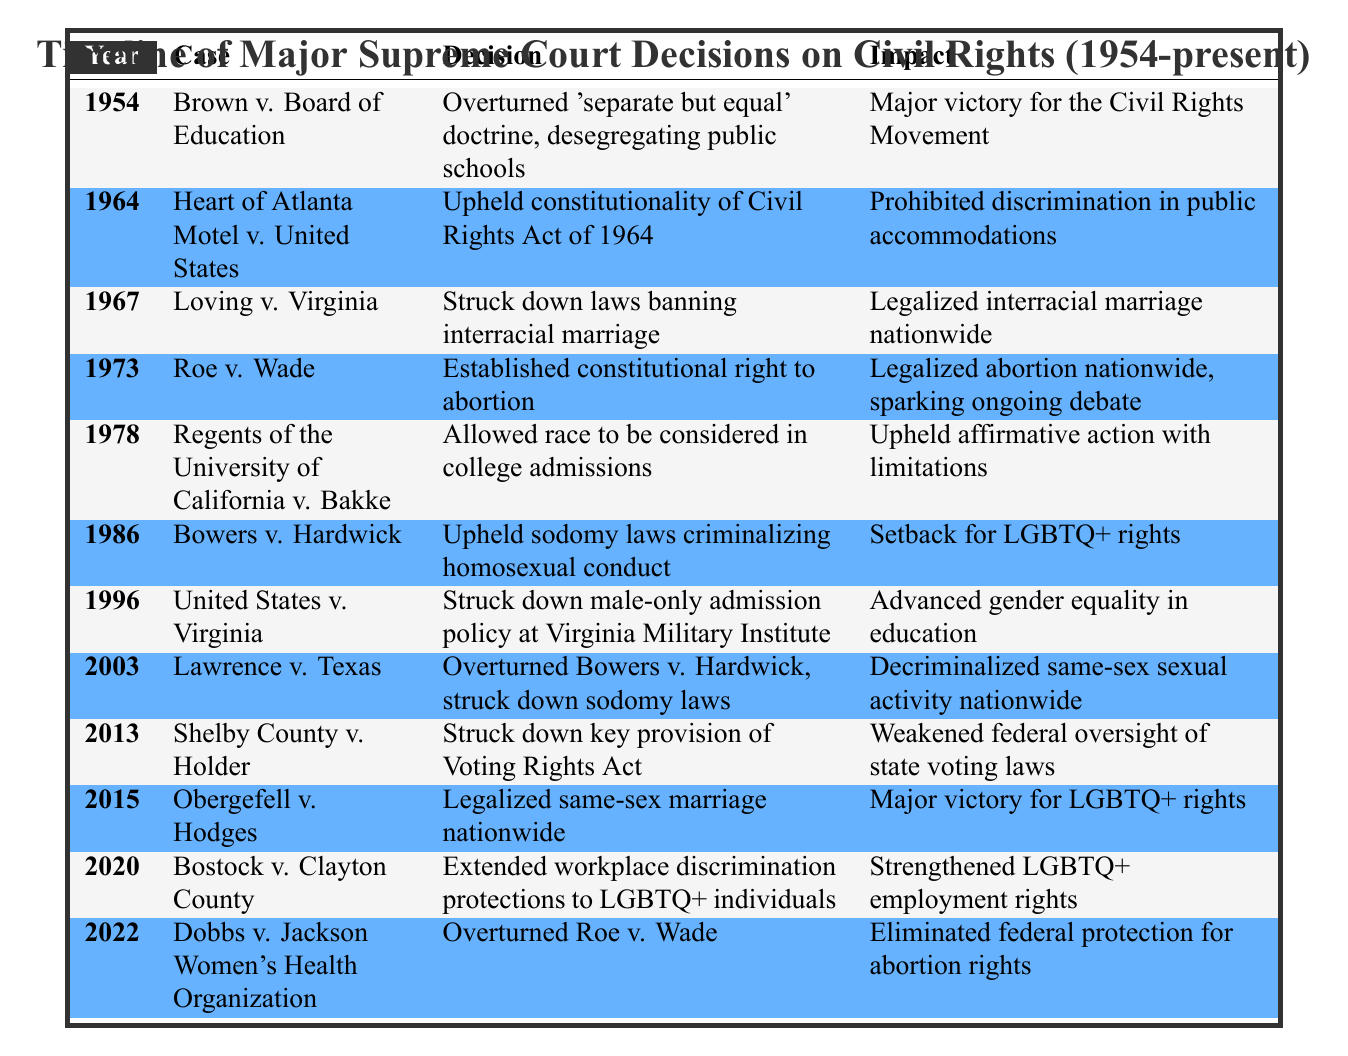What was the decision in Brown v. Board of Education? The table states that the decision in the case of Brown v. Board of Education was to overturn the 'separate but equal' doctrine, which led to the desegregation of public schools.
Answer: Overturned 'separate but equal' doctrine, desegregating public schools Which case legalized same-sex marriage nationwide? According to the timeline, the case that legalized same-sex marriage nationwide is Obergefell v. Hodges.
Answer: Obergefell v. Hodges True or False: The case of Roe v. Wade legalized abortion nationwide. The impact listed in the table for Roe v. Wade indicates that it established a constitutional right to abortion, thus legalizing it nationwide. Therefore, the statement is true.
Answer: True What year did the Supreme Court strike down laws banning interracial marriage? From the table, Loving v. Virginia, which struck down laws banning interracial marriage, was decided in 1967.
Answer: 1967 How many cases were decided between 1970 and 1980 that impacted civil rights? Referring to the table, we identify three cases from the years between 1970 and 1980: Roe v. Wade (1973), Regents of the University of California v. Bakke (1978), and Bowers v. Hardwick (1986, which is just beyond 1980). Thus, there are two cases from that decade, making the count two.
Answer: 2 Which case weakened federal oversight of state voting laws? The entry for Shelby County v. Holder notes that it struck down a key provision of the Voting Rights Act, leading to weakened federal oversight of state voting laws.
Answer: Shelby County v. Holder True or False: The decision in Lawrence v. Texas upheld sodomy laws. The table describes Lawrence v. Texas as having overturned Bowers v. Hardwick and struck down sodomy laws, indicating that it did not uphold them. Thus, the statement is false.
Answer: False Which case allowed race to be considered in college admissions? The decision noted in Regents of the University of California v. Bakke states that it allowed race to be considered in college admissions, thereby impacting the affirmative action policies of educational institutions.
Answer: Regents of the University of California v. Bakke What impact did Bostock v. Clayton County have on LGBTQ+ employment rights? The timeline notes that Bostock v. Clayton County extended workplace discrimination protections to LGBTQ+ individuals, which strengthened their employment rights.
Answer: Strengthened LGBTQ+ employment rights 